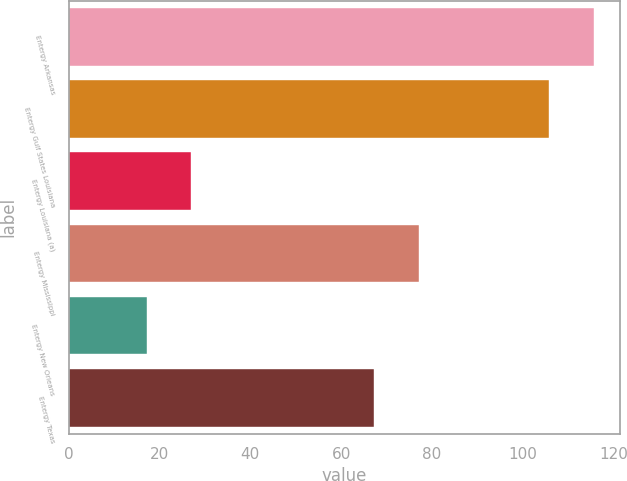<chart> <loc_0><loc_0><loc_500><loc_500><bar_chart><fcel>Entergy Arkansas<fcel>Entergy Gulf States Louisiana<fcel>Entergy Louisiana (a)<fcel>Entergy Mississippi<fcel>Entergy New Orleans<fcel>Entergy Texas<nl><fcel>115.55<fcel>105.8<fcel>27.05<fcel>77.05<fcel>17.3<fcel>67.3<nl></chart> 